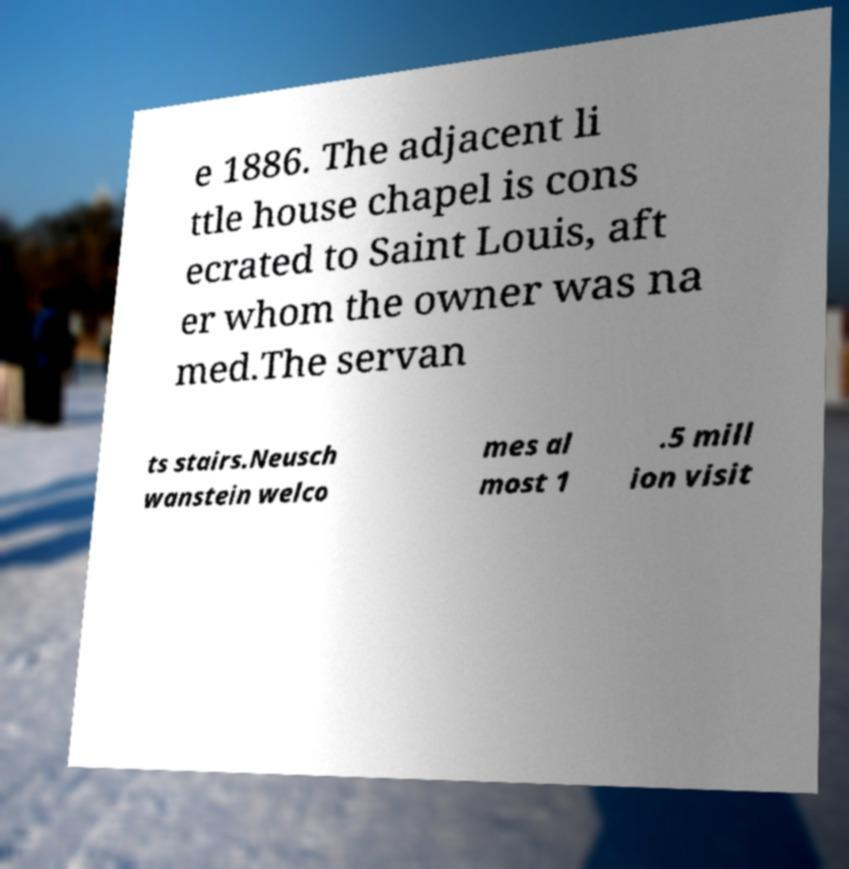Could you assist in decoding the text presented in this image and type it out clearly? e 1886. The adjacent li ttle house chapel is cons ecrated to Saint Louis, aft er whom the owner was na med.The servan ts stairs.Neusch wanstein welco mes al most 1 .5 mill ion visit 